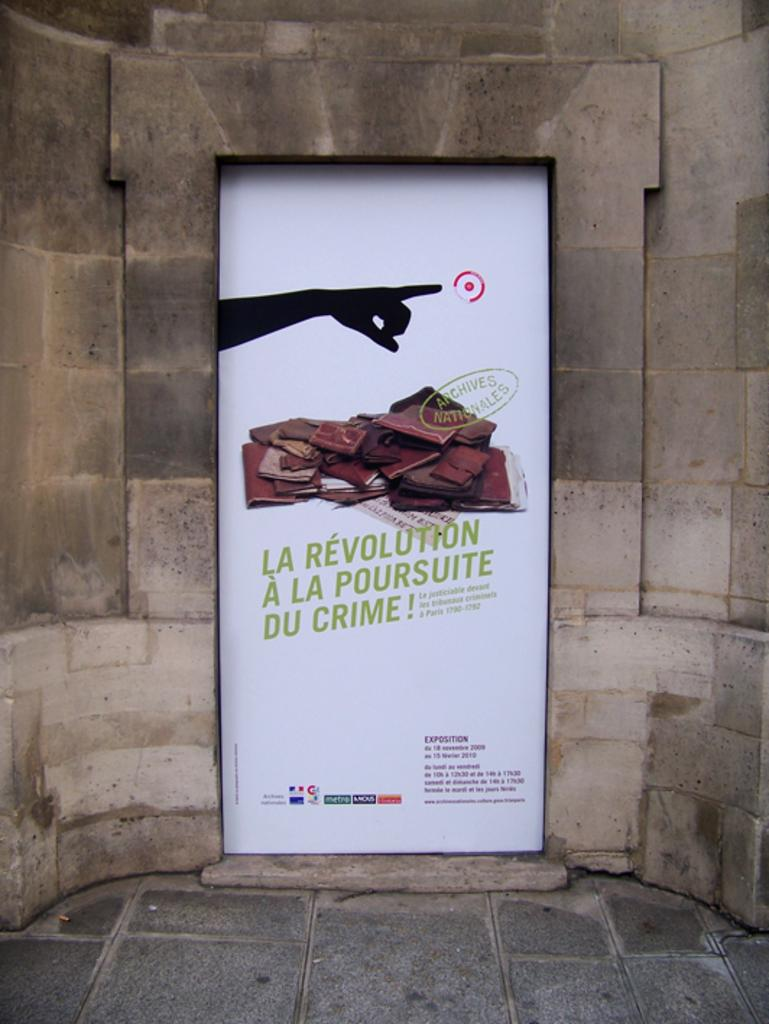What is the color of the poster in the image? The poster in the image is white. What is shown on the poster? The poster depicts a hand of a person. What else can be seen in the image besides the poster? There is a wall visible in the image. How many corks are attached to the wall in the image? There is no mention of corks in the image, so it is impossible to determine how many are attached to the wall. 